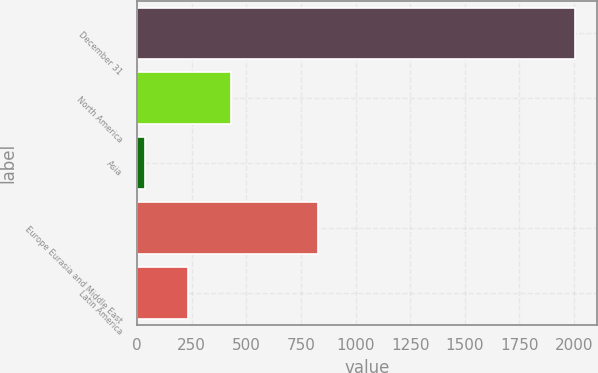Convert chart. <chart><loc_0><loc_0><loc_500><loc_500><bar_chart><fcel>December 31<fcel>North America<fcel>Asia<fcel>Europe Eurasia and Middle East<fcel>Latin America<nl><fcel>2004<fcel>430.4<fcel>37<fcel>828<fcel>233.7<nl></chart> 